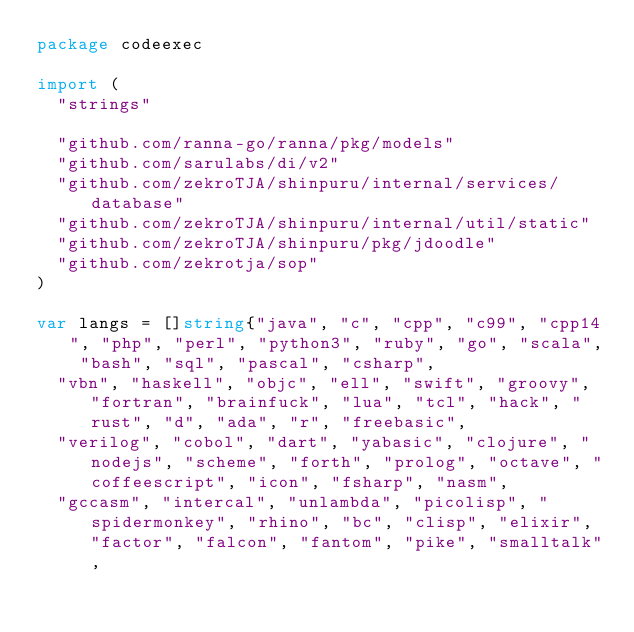<code> <loc_0><loc_0><loc_500><loc_500><_Go_>package codeexec

import (
	"strings"

	"github.com/ranna-go/ranna/pkg/models"
	"github.com/sarulabs/di/v2"
	"github.com/zekroTJA/shinpuru/internal/services/database"
	"github.com/zekroTJA/shinpuru/internal/util/static"
	"github.com/zekroTJA/shinpuru/pkg/jdoodle"
	"github.com/zekrotja/sop"
)

var langs = []string{"java", "c", "cpp", "c99", "cpp14", "php", "perl", "python3", "ruby", "go", "scala", "bash", "sql", "pascal", "csharp",
	"vbn", "haskell", "objc", "ell", "swift", "groovy", "fortran", "brainfuck", "lua", "tcl", "hack", "rust", "d", "ada", "r", "freebasic",
	"verilog", "cobol", "dart", "yabasic", "clojure", "nodejs", "scheme", "forth", "prolog", "octave", "coffeescript", "icon", "fsharp", "nasm",
	"gccasm", "intercal", "unlambda", "picolisp", "spidermonkey", "rhino", "bc", "clisp", "elixir", "factor", "falcon", "fantom", "pike", "smalltalk",</code> 